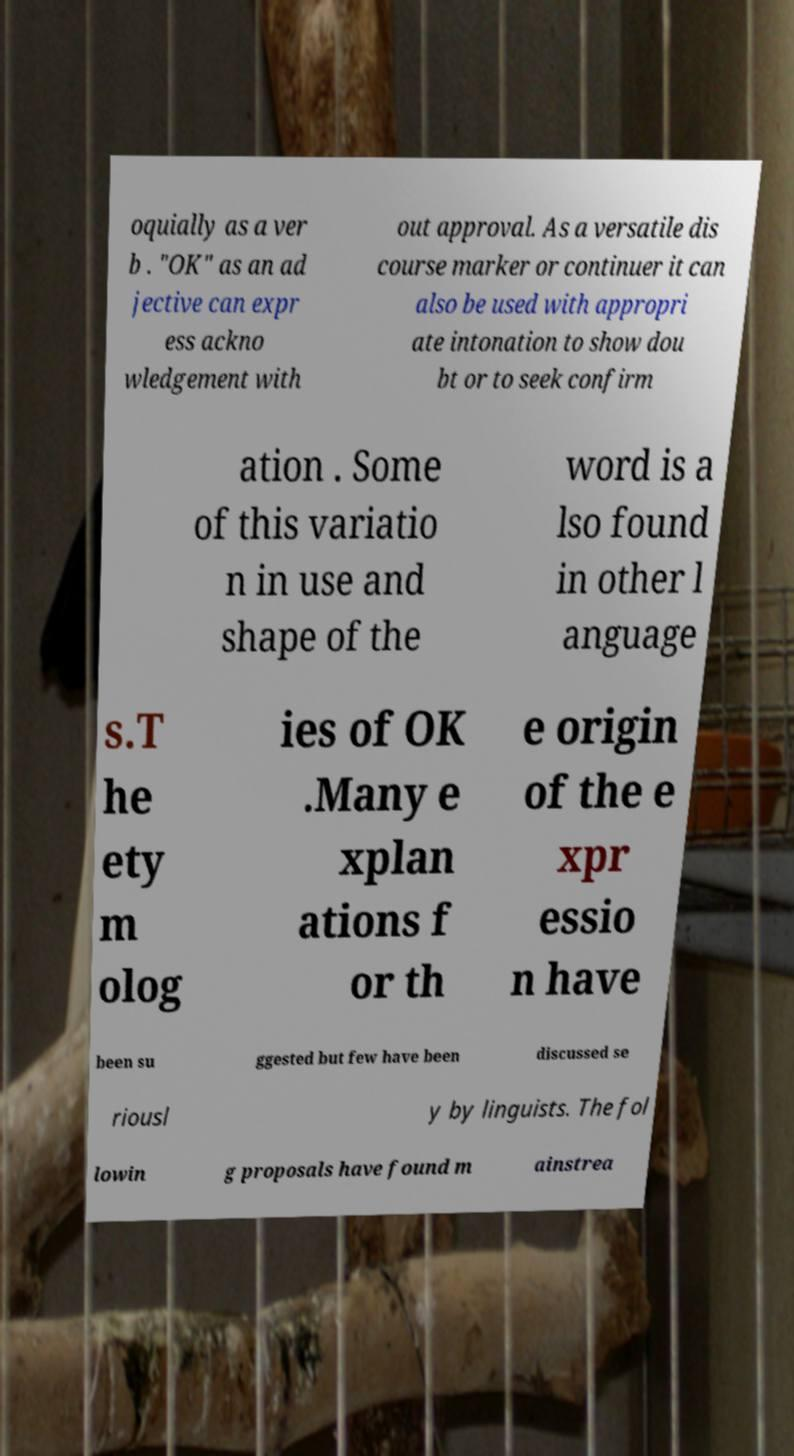There's text embedded in this image that I need extracted. Can you transcribe it verbatim? oquially as a ver b . "OK" as an ad jective can expr ess ackno wledgement with out approval. As a versatile dis course marker or continuer it can also be used with appropri ate intonation to show dou bt or to seek confirm ation . Some of this variatio n in use and shape of the word is a lso found in other l anguage s.T he ety m olog ies of OK .Many e xplan ations f or th e origin of the e xpr essio n have been su ggested but few have been discussed se riousl y by linguists. The fol lowin g proposals have found m ainstrea 